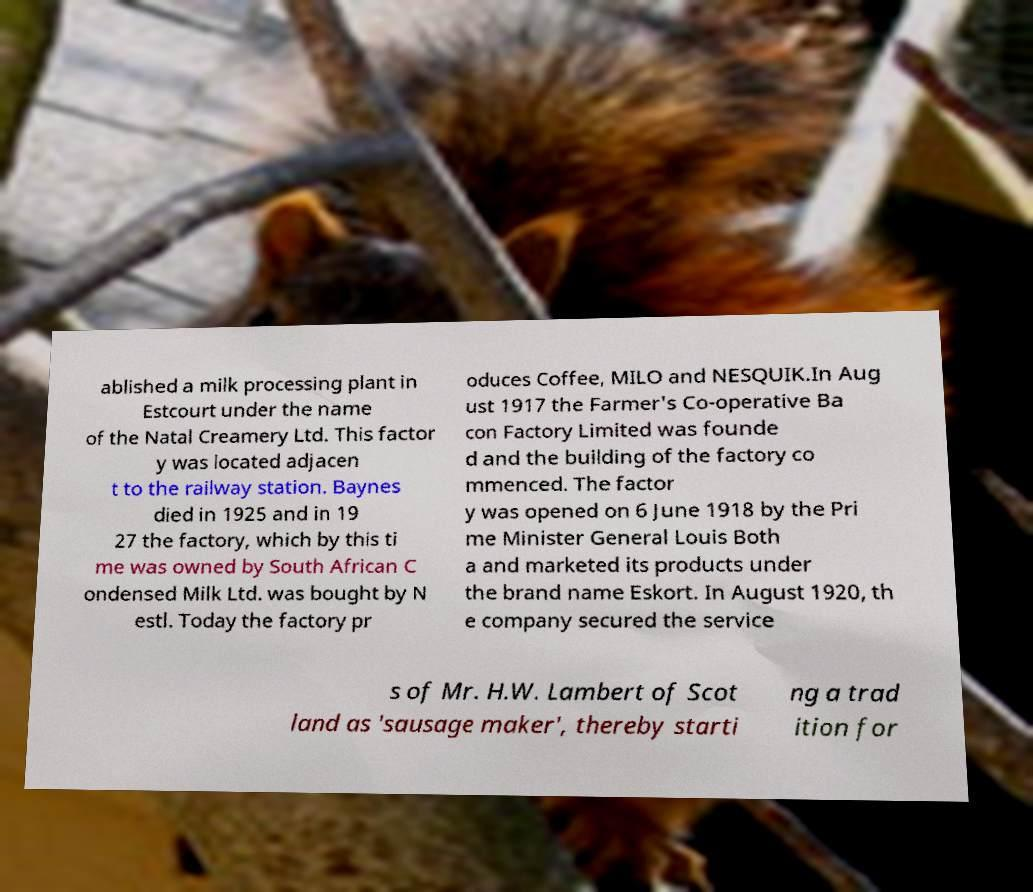Can you read and provide the text displayed in the image?This photo seems to have some interesting text. Can you extract and type it out for me? ablished a milk processing plant in Estcourt under the name of the Natal Creamery Ltd. This factor y was located adjacen t to the railway station. Baynes died in 1925 and in 19 27 the factory, which by this ti me was owned by South African C ondensed Milk Ltd. was bought by N estl. Today the factory pr oduces Coffee, MILO and NESQUIK.In Aug ust 1917 the Farmer's Co-operative Ba con Factory Limited was founde d and the building of the factory co mmenced. The factor y was opened on 6 June 1918 by the Pri me Minister General Louis Both a and marketed its products under the brand name Eskort. In August 1920, th e company secured the service s of Mr. H.W. Lambert of Scot land as 'sausage maker', thereby starti ng a trad ition for 